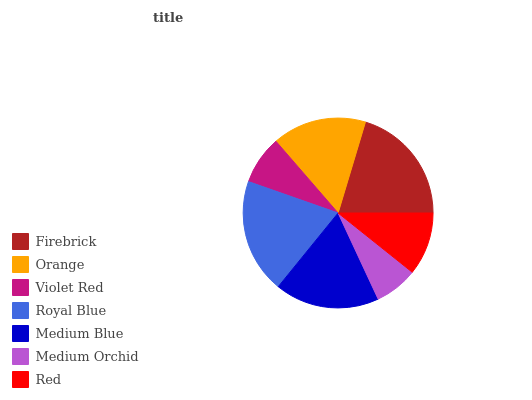Is Medium Orchid the minimum?
Answer yes or no. Yes. Is Firebrick the maximum?
Answer yes or no. Yes. Is Orange the minimum?
Answer yes or no. No. Is Orange the maximum?
Answer yes or no. No. Is Firebrick greater than Orange?
Answer yes or no. Yes. Is Orange less than Firebrick?
Answer yes or no. Yes. Is Orange greater than Firebrick?
Answer yes or no. No. Is Firebrick less than Orange?
Answer yes or no. No. Is Orange the high median?
Answer yes or no. Yes. Is Orange the low median?
Answer yes or no. Yes. Is Violet Red the high median?
Answer yes or no. No. Is Firebrick the low median?
Answer yes or no. No. 